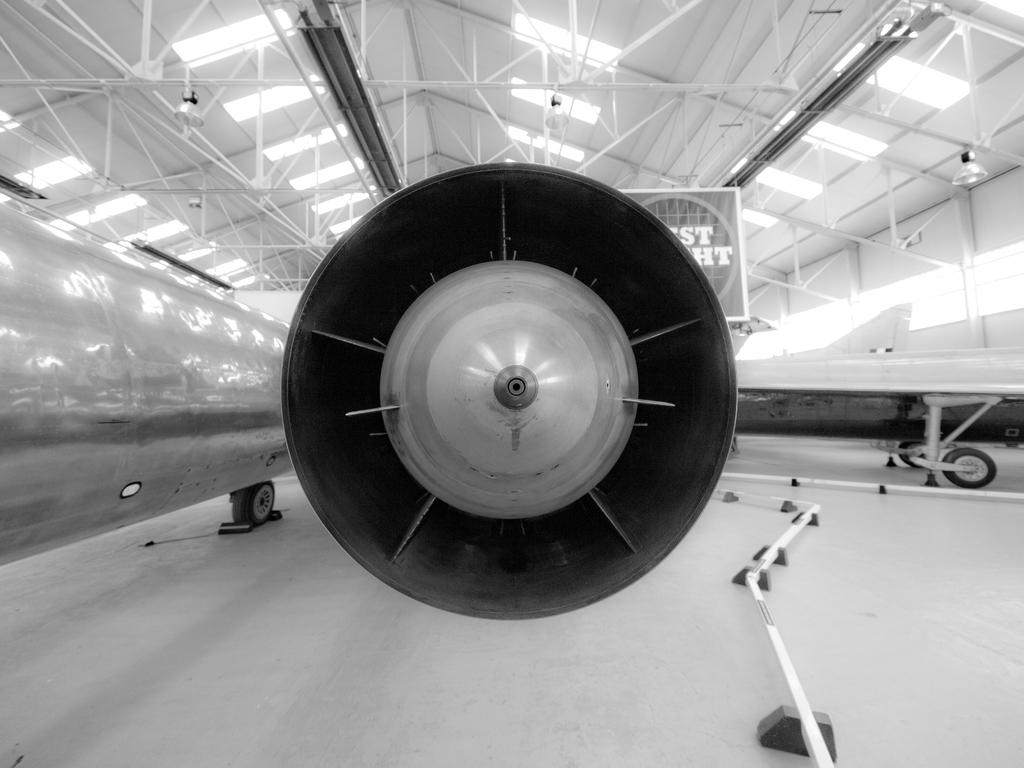What is the color scheme of the image? The image is black and white. What is the main subject in the center of the image? There is an aeroplane in the center of the image. What can be seen at the top of the image? There is a ceiling with rods at the top of the image. What is located at the bottom of the image? There is a floor at the bottom of the image. How does the income of the people in the image affect the intensity of the rainstorm? There is no mention of income or rainstorm in the image, as it only features an aeroplane and a ceiling with rods. 